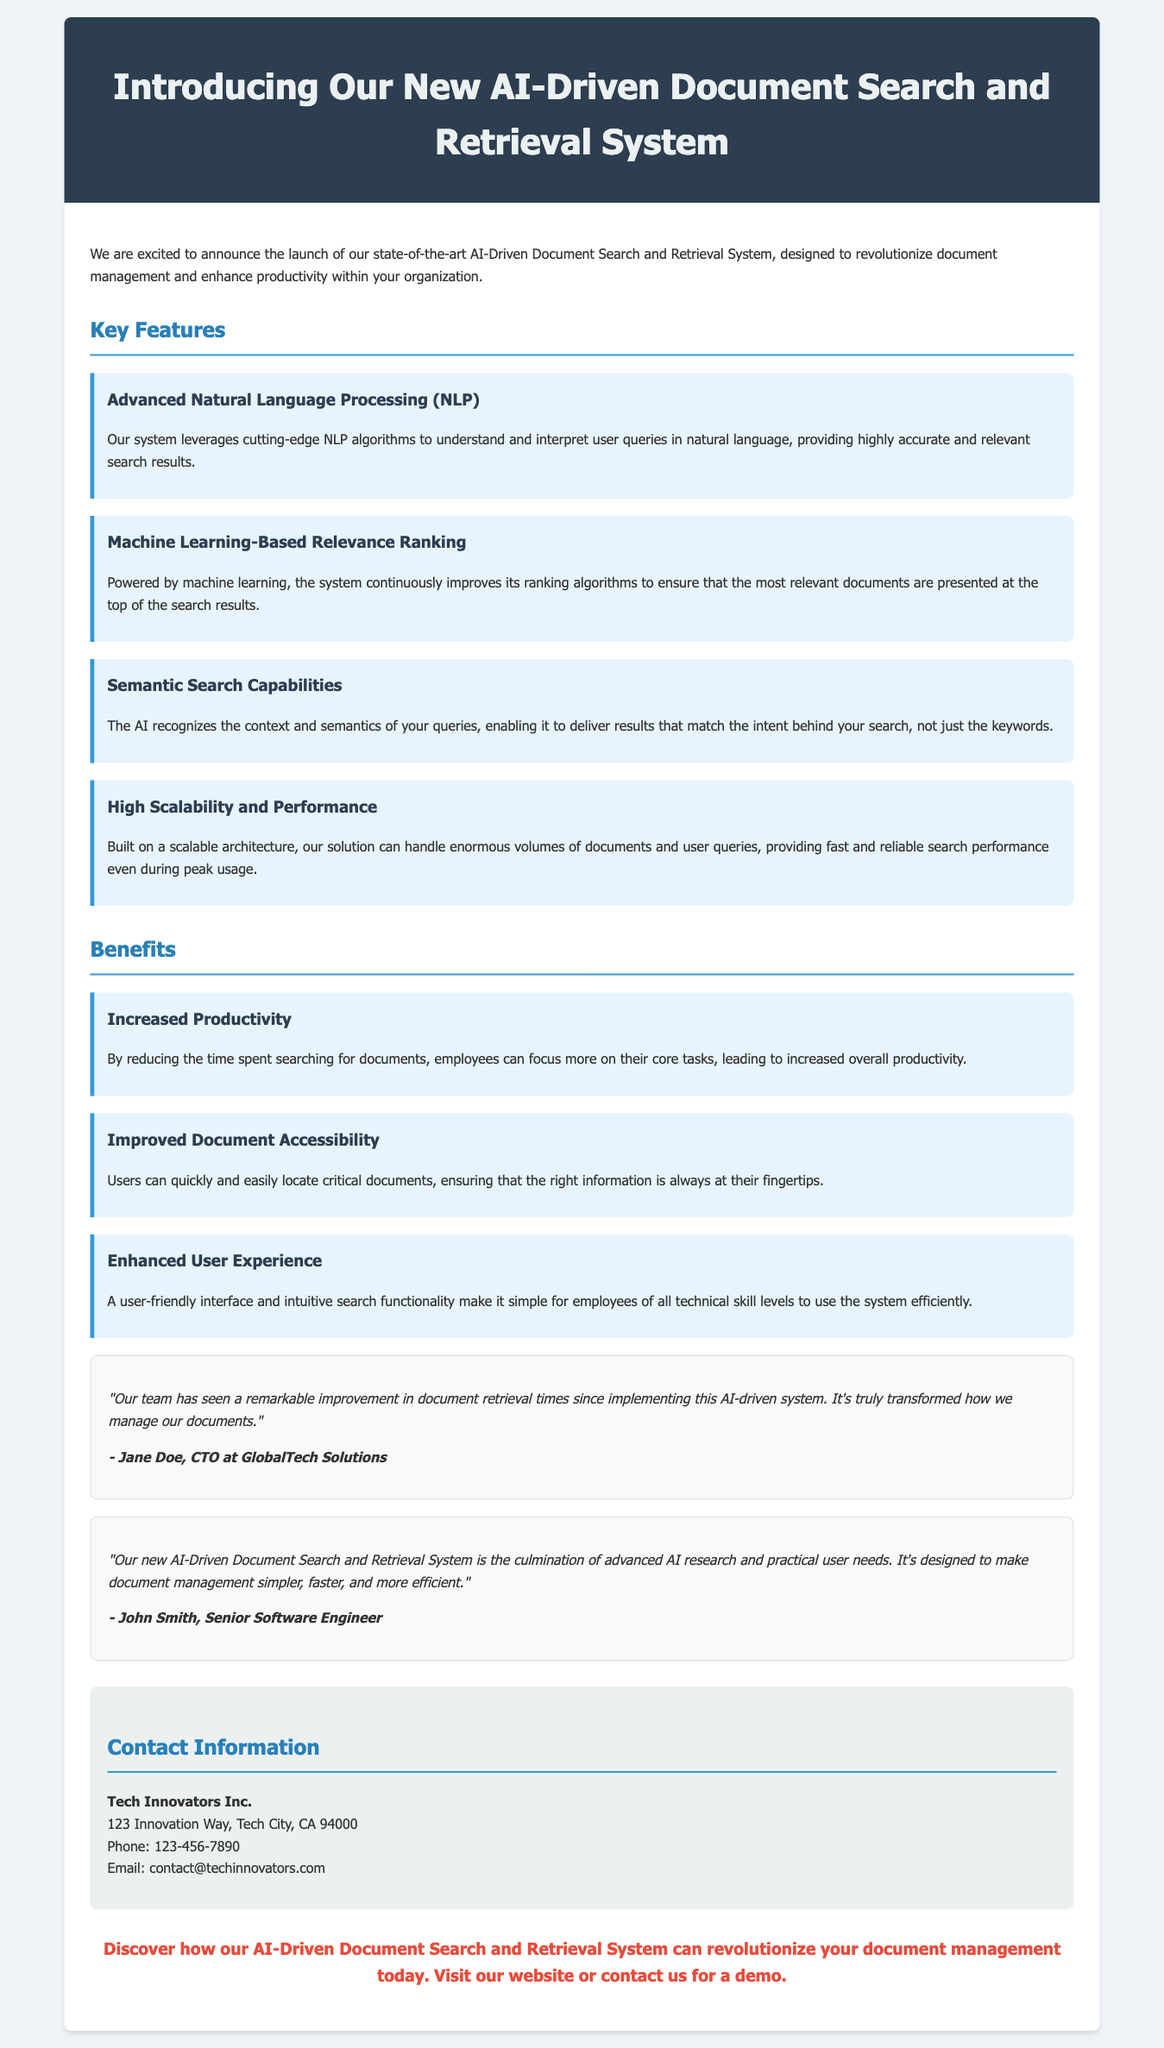What is the name of the new system? The document introduces a new AI-Driven Document Search and Retrieval System.
Answer: AI-Driven Document Search and Retrieval System Who is mentioned as the CTO at GlobalTech Solutions? Jane Doe is cited as the CTO providing a testimonial about the system.
Answer: Jane Doe What key feature involves understanding user queries? The document describes a feature that uses NLP algorithms to interpret user queries.
Answer: Advanced Natural Language Processing (NLP) What benefit is highlighted for employee productivity? The press release states that reducing search time leads to increased overall productivity.
Answer: Increased Productivity What kind of search capabilities does the AI system have? The document mentions that the AI system includes semantic search capabilities to understand the intent behind queries.
Answer: Semantic Search Capabilities How can users contact Tech Innovators Inc.? The document provides contact information for Tech Innovators Inc., including phone and email.
Answer: Phone: 123-456-7890, Email: contact@techinnovators.com What is the purpose of the document? The main purpose is to announce the launch of a new AI-driven system designed to enhance document management.
Answer: To announce the launch Who is the senior software engineer quoted in the document? The quote in the document is attributed to John Smith, who discusses the system's design.
Answer: John Smith 